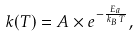<formula> <loc_0><loc_0><loc_500><loc_500>k ( T ) = A \times e ^ { - \frac { E _ { a } } { k _ { B } \, T } } ,</formula> 